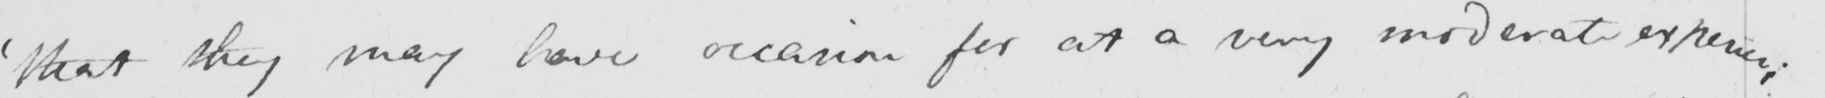What text is written in this handwritten line? ' that they may have occasion for at a very moderate expence ; 